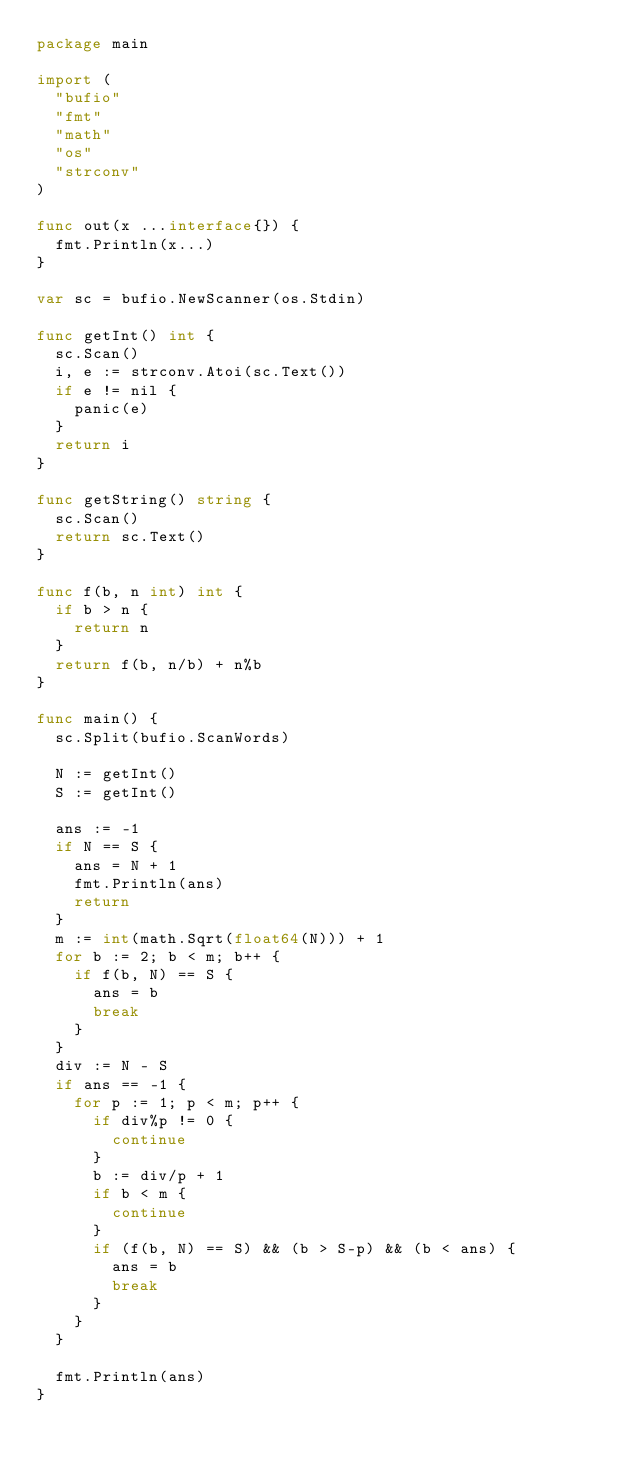Convert code to text. <code><loc_0><loc_0><loc_500><loc_500><_Go_>package main

import (
	"bufio"
	"fmt"
	"math"
	"os"
	"strconv"
)

func out(x ...interface{}) {
	fmt.Println(x...)
}

var sc = bufio.NewScanner(os.Stdin)

func getInt() int {
	sc.Scan()
	i, e := strconv.Atoi(sc.Text())
	if e != nil {
		panic(e)
	}
	return i
}

func getString() string {
	sc.Scan()
	return sc.Text()
}

func f(b, n int) int {
	if b > n {
		return n
	}
	return f(b, n/b) + n%b
}

func main() {
	sc.Split(bufio.ScanWords)

	N := getInt()
	S := getInt()

	ans := -1
	if N == S {
		ans = N + 1
		fmt.Println(ans)
		return
	}
	m := int(math.Sqrt(float64(N))) + 1
	for b := 2; b < m; b++ {
		if f(b, N) == S {
			ans = b
			break
		}
	}
	div := N - S
	if ans == -1 {
		for p := 1; p < m; p++ {
			if div%p != 0 {
				continue
			}
			b := div/p + 1
			if b < m {
				continue
			}
			if (f(b, N) == S) && (b > S-p) && (b < ans) {
				ans = b
				break
			}
		}
	}

	fmt.Println(ans)
}
</code> 